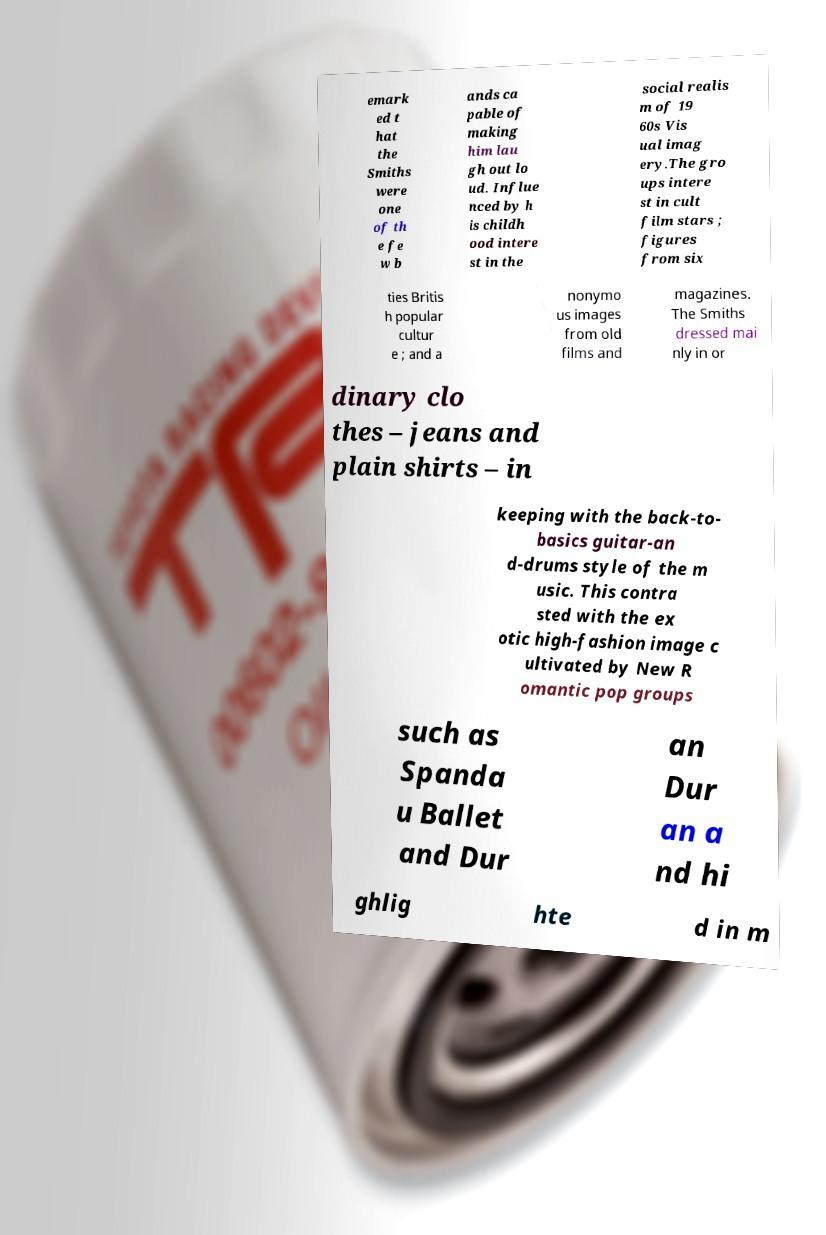There's text embedded in this image that I need extracted. Can you transcribe it verbatim? emark ed t hat the Smiths were one of th e fe w b ands ca pable of making him lau gh out lo ud. Influe nced by h is childh ood intere st in the social realis m of 19 60s Vis ual imag ery.The gro ups intere st in cult film stars ; figures from six ties Britis h popular cultur e ; and a nonymo us images from old films and magazines. The Smiths dressed mai nly in or dinary clo thes – jeans and plain shirts – in keeping with the back-to- basics guitar-an d-drums style of the m usic. This contra sted with the ex otic high-fashion image c ultivated by New R omantic pop groups such as Spanda u Ballet and Dur an Dur an a nd hi ghlig hte d in m 